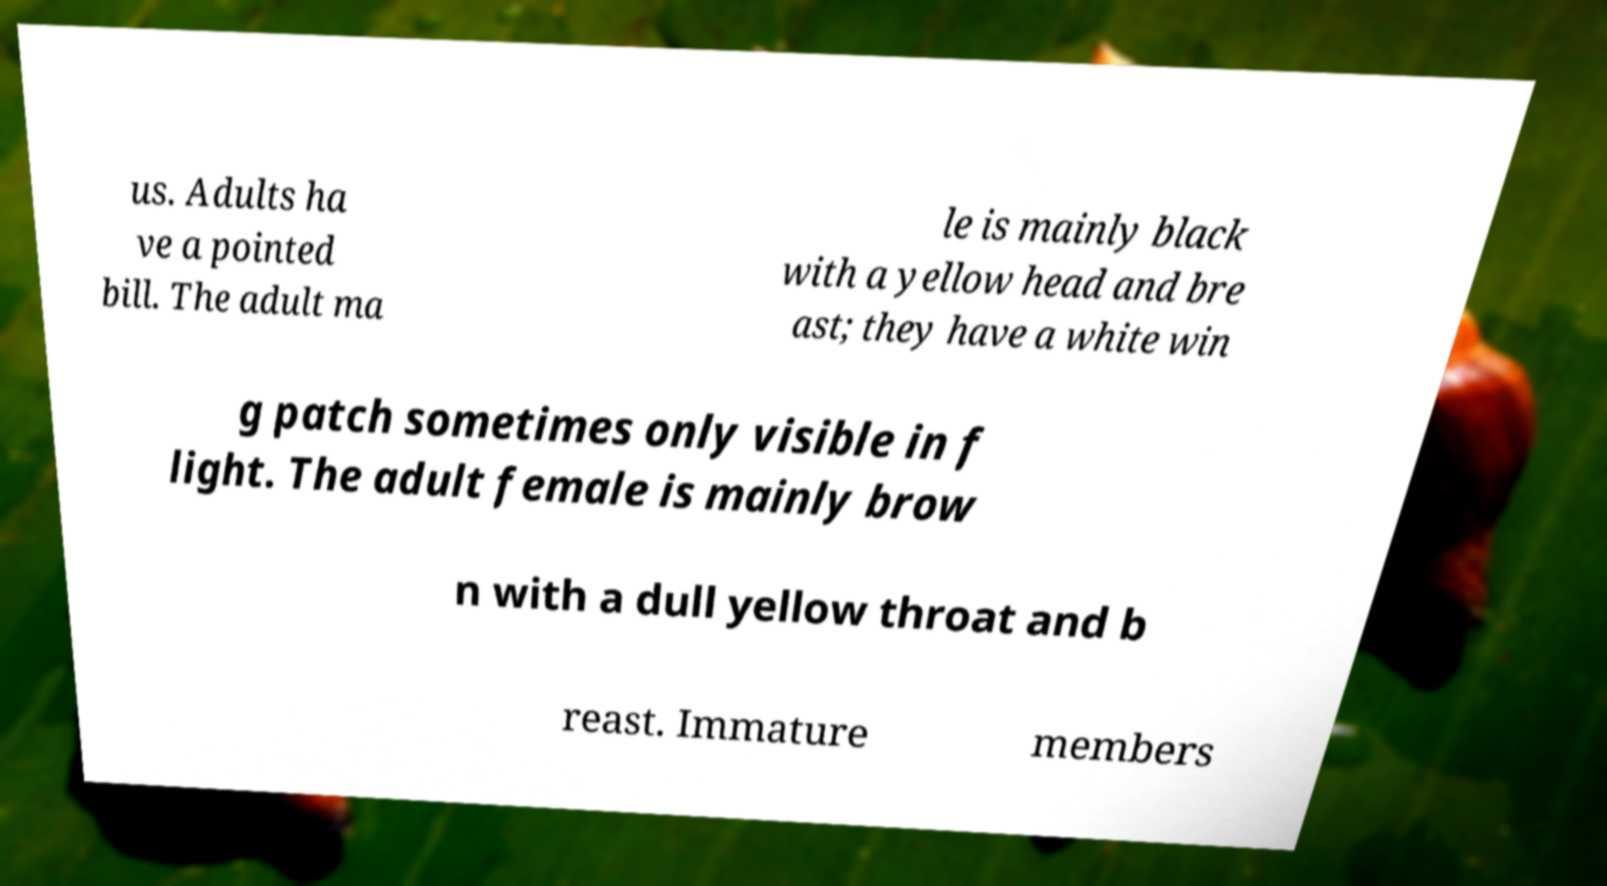I need the written content from this picture converted into text. Can you do that? us. Adults ha ve a pointed bill. The adult ma le is mainly black with a yellow head and bre ast; they have a white win g patch sometimes only visible in f light. The adult female is mainly brow n with a dull yellow throat and b reast. Immature members 